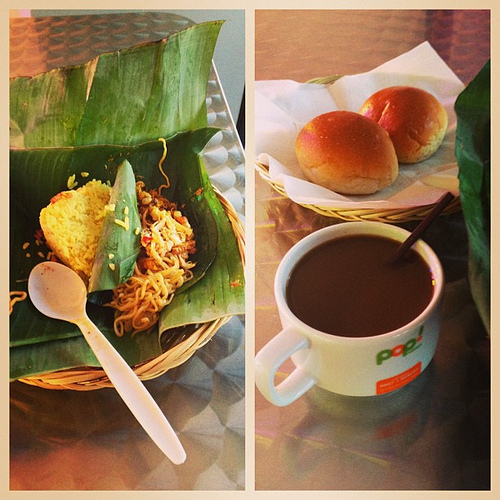What is the drink to the right of the food that is to the right of the food? To the right of the noodles, the drink you're looking at is a warm, inviting mug of coffee, perfect for complementing the meal. 